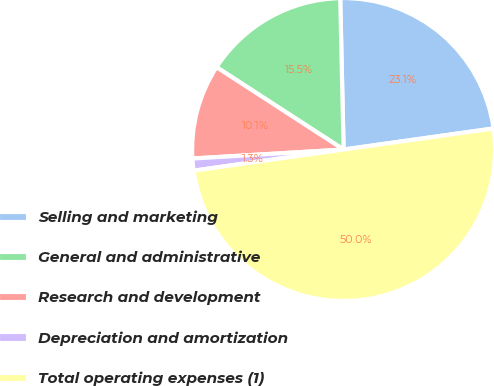<chart> <loc_0><loc_0><loc_500><loc_500><pie_chart><fcel>Selling and marketing<fcel>General and administrative<fcel>Research and development<fcel>Depreciation and amortization<fcel>Total operating expenses (1)<nl><fcel>23.13%<fcel>15.49%<fcel>10.1%<fcel>1.28%<fcel>50.0%<nl></chart> 